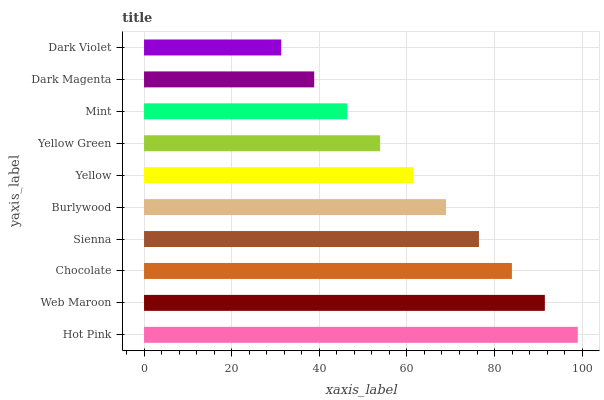Is Dark Violet the minimum?
Answer yes or no. Yes. Is Hot Pink the maximum?
Answer yes or no. Yes. Is Web Maroon the minimum?
Answer yes or no. No. Is Web Maroon the maximum?
Answer yes or no. No. Is Hot Pink greater than Web Maroon?
Answer yes or no. Yes. Is Web Maroon less than Hot Pink?
Answer yes or no. Yes. Is Web Maroon greater than Hot Pink?
Answer yes or no. No. Is Hot Pink less than Web Maroon?
Answer yes or no. No. Is Burlywood the high median?
Answer yes or no. Yes. Is Yellow the low median?
Answer yes or no. Yes. Is Dark Magenta the high median?
Answer yes or no. No. Is Hot Pink the low median?
Answer yes or no. No. 